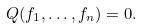<formula> <loc_0><loc_0><loc_500><loc_500>Q ( f _ { 1 } , \dots , f _ { n } ) = 0 .</formula> 